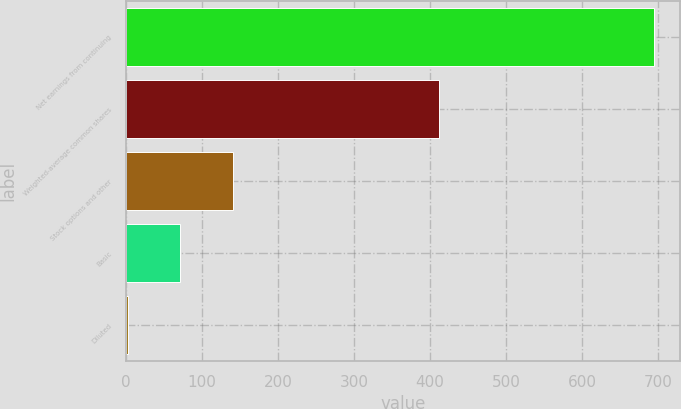<chart> <loc_0><loc_0><loc_500><loc_500><bar_chart><fcel>Net earnings from continuing<fcel>Weighted-average common shares<fcel>Stock options and other<fcel>Basic<fcel>Diluted<nl><fcel>695<fcel>411.4<fcel>140.6<fcel>71.3<fcel>2<nl></chart> 